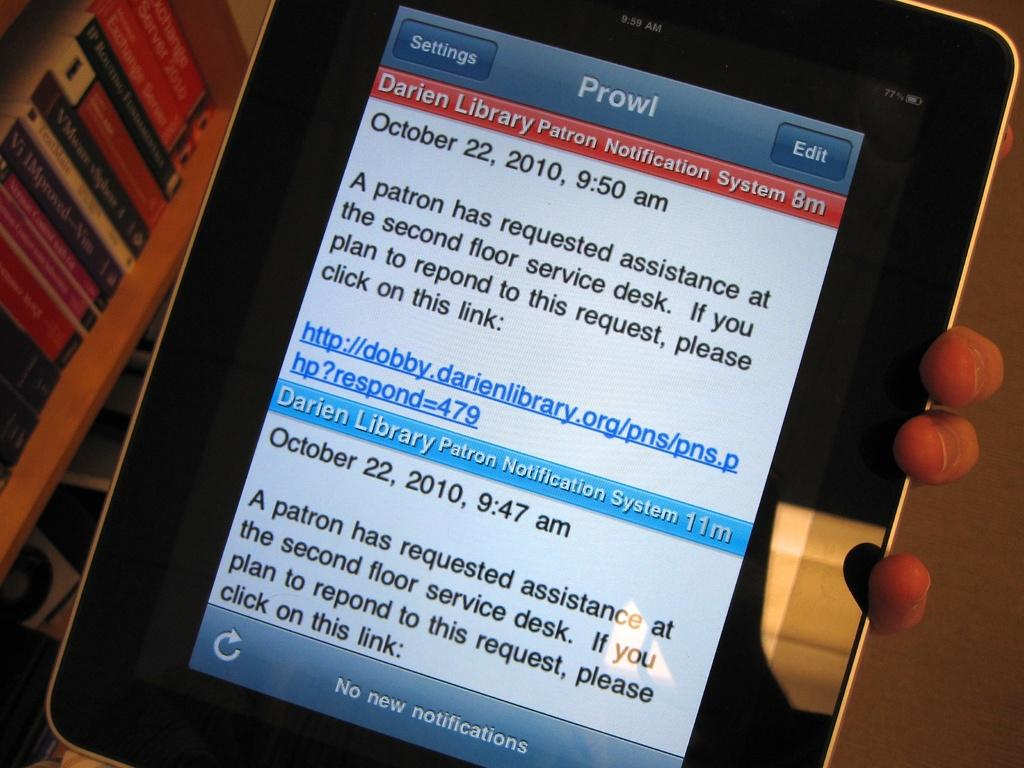Provide a one-sentence caption for the provided image. An ipad with a notification from "Prowl" alerting someone a patron needs assistance at the front desk of a Library. 